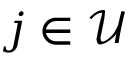Convert formula to latex. <formula><loc_0><loc_0><loc_500><loc_500>j \in \mathcal { U }</formula> 